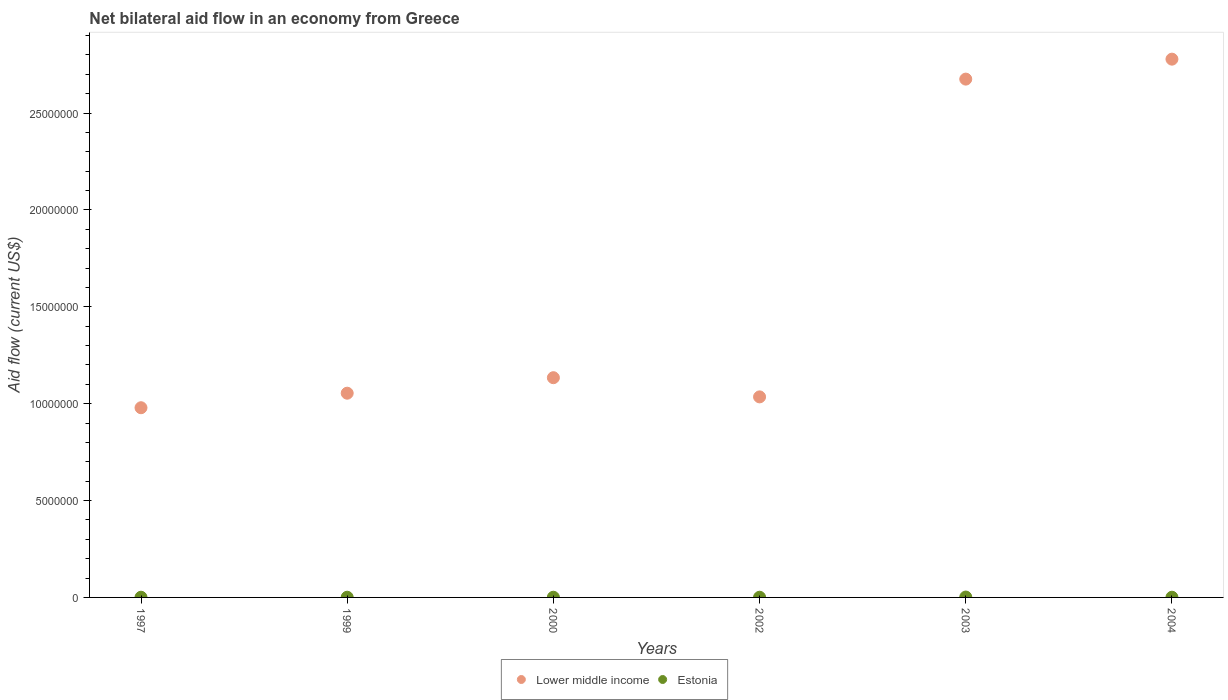Is the number of dotlines equal to the number of legend labels?
Your answer should be very brief. Yes. What is the net bilateral aid flow in Estonia in 2004?
Offer a very short reply. 10000. Across all years, what is the minimum net bilateral aid flow in Lower middle income?
Your response must be concise. 9.79e+06. What is the total net bilateral aid flow in Estonia in the graph?
Keep it short and to the point. 7.00e+04. What is the difference between the net bilateral aid flow in Lower middle income in 1999 and that in 2004?
Offer a terse response. -1.72e+07. What is the difference between the net bilateral aid flow in Lower middle income in 1999 and the net bilateral aid flow in Estonia in 2000?
Ensure brevity in your answer.  1.05e+07. What is the average net bilateral aid flow in Estonia per year?
Give a very brief answer. 1.17e+04. In the year 2004, what is the difference between the net bilateral aid flow in Lower middle income and net bilateral aid flow in Estonia?
Ensure brevity in your answer.  2.78e+07. In how many years, is the net bilateral aid flow in Estonia greater than 24000000 US$?
Your answer should be very brief. 0. What is the ratio of the net bilateral aid flow in Lower middle income in 2003 to that in 2004?
Your answer should be very brief. 0.96. Is the difference between the net bilateral aid flow in Lower middle income in 2000 and 2003 greater than the difference between the net bilateral aid flow in Estonia in 2000 and 2003?
Ensure brevity in your answer.  No. What is the difference between the highest and the lowest net bilateral aid flow in Lower middle income?
Ensure brevity in your answer.  1.80e+07. In how many years, is the net bilateral aid flow in Lower middle income greater than the average net bilateral aid flow in Lower middle income taken over all years?
Offer a terse response. 2. Is the sum of the net bilateral aid flow in Estonia in 1997 and 1999 greater than the maximum net bilateral aid flow in Lower middle income across all years?
Provide a succinct answer. No. How many dotlines are there?
Keep it short and to the point. 2. What is the difference between two consecutive major ticks on the Y-axis?
Your answer should be compact. 5.00e+06. Are the values on the major ticks of Y-axis written in scientific E-notation?
Give a very brief answer. No. How many legend labels are there?
Provide a succinct answer. 2. How are the legend labels stacked?
Ensure brevity in your answer.  Horizontal. What is the title of the graph?
Give a very brief answer. Net bilateral aid flow in an economy from Greece. Does "Cabo Verde" appear as one of the legend labels in the graph?
Offer a very short reply. No. What is the label or title of the X-axis?
Provide a short and direct response. Years. What is the label or title of the Y-axis?
Provide a succinct answer. Aid flow (current US$). What is the Aid flow (current US$) of Lower middle income in 1997?
Keep it short and to the point. 9.79e+06. What is the Aid flow (current US$) of Lower middle income in 1999?
Give a very brief answer. 1.05e+07. What is the Aid flow (current US$) of Estonia in 1999?
Offer a very short reply. 10000. What is the Aid flow (current US$) in Lower middle income in 2000?
Provide a short and direct response. 1.13e+07. What is the Aid flow (current US$) of Estonia in 2000?
Give a very brief answer. 10000. What is the Aid flow (current US$) of Lower middle income in 2002?
Make the answer very short. 1.04e+07. What is the Aid flow (current US$) of Estonia in 2002?
Your answer should be very brief. 10000. What is the Aid flow (current US$) of Lower middle income in 2003?
Provide a succinct answer. 2.68e+07. What is the Aid flow (current US$) of Estonia in 2003?
Provide a short and direct response. 2.00e+04. What is the Aid flow (current US$) of Lower middle income in 2004?
Make the answer very short. 2.78e+07. Across all years, what is the maximum Aid flow (current US$) of Lower middle income?
Ensure brevity in your answer.  2.78e+07. Across all years, what is the minimum Aid flow (current US$) of Lower middle income?
Make the answer very short. 9.79e+06. What is the total Aid flow (current US$) of Lower middle income in the graph?
Offer a terse response. 9.66e+07. What is the total Aid flow (current US$) of Estonia in the graph?
Provide a succinct answer. 7.00e+04. What is the difference between the Aid flow (current US$) in Lower middle income in 1997 and that in 1999?
Keep it short and to the point. -7.50e+05. What is the difference between the Aid flow (current US$) of Estonia in 1997 and that in 1999?
Offer a terse response. 0. What is the difference between the Aid flow (current US$) in Lower middle income in 1997 and that in 2000?
Give a very brief answer. -1.55e+06. What is the difference between the Aid flow (current US$) in Estonia in 1997 and that in 2000?
Provide a succinct answer. 0. What is the difference between the Aid flow (current US$) in Lower middle income in 1997 and that in 2002?
Make the answer very short. -5.60e+05. What is the difference between the Aid flow (current US$) of Lower middle income in 1997 and that in 2003?
Ensure brevity in your answer.  -1.70e+07. What is the difference between the Aid flow (current US$) of Estonia in 1997 and that in 2003?
Offer a very short reply. -10000. What is the difference between the Aid flow (current US$) in Lower middle income in 1997 and that in 2004?
Provide a succinct answer. -1.80e+07. What is the difference between the Aid flow (current US$) of Estonia in 1997 and that in 2004?
Provide a succinct answer. 0. What is the difference between the Aid flow (current US$) of Lower middle income in 1999 and that in 2000?
Provide a succinct answer. -8.00e+05. What is the difference between the Aid flow (current US$) of Estonia in 1999 and that in 2002?
Your answer should be very brief. 0. What is the difference between the Aid flow (current US$) of Lower middle income in 1999 and that in 2003?
Your answer should be compact. -1.62e+07. What is the difference between the Aid flow (current US$) of Lower middle income in 1999 and that in 2004?
Make the answer very short. -1.72e+07. What is the difference between the Aid flow (current US$) in Lower middle income in 2000 and that in 2002?
Ensure brevity in your answer.  9.90e+05. What is the difference between the Aid flow (current US$) of Estonia in 2000 and that in 2002?
Provide a succinct answer. 0. What is the difference between the Aid flow (current US$) of Lower middle income in 2000 and that in 2003?
Provide a short and direct response. -1.54e+07. What is the difference between the Aid flow (current US$) in Lower middle income in 2000 and that in 2004?
Give a very brief answer. -1.64e+07. What is the difference between the Aid flow (current US$) of Lower middle income in 2002 and that in 2003?
Keep it short and to the point. -1.64e+07. What is the difference between the Aid flow (current US$) of Lower middle income in 2002 and that in 2004?
Make the answer very short. -1.74e+07. What is the difference between the Aid flow (current US$) in Estonia in 2002 and that in 2004?
Give a very brief answer. 0. What is the difference between the Aid flow (current US$) of Lower middle income in 2003 and that in 2004?
Offer a very short reply. -1.03e+06. What is the difference between the Aid flow (current US$) in Estonia in 2003 and that in 2004?
Keep it short and to the point. 10000. What is the difference between the Aid flow (current US$) of Lower middle income in 1997 and the Aid flow (current US$) of Estonia in 1999?
Offer a terse response. 9.78e+06. What is the difference between the Aid flow (current US$) of Lower middle income in 1997 and the Aid flow (current US$) of Estonia in 2000?
Offer a very short reply. 9.78e+06. What is the difference between the Aid flow (current US$) in Lower middle income in 1997 and the Aid flow (current US$) in Estonia in 2002?
Give a very brief answer. 9.78e+06. What is the difference between the Aid flow (current US$) of Lower middle income in 1997 and the Aid flow (current US$) of Estonia in 2003?
Your response must be concise. 9.77e+06. What is the difference between the Aid flow (current US$) of Lower middle income in 1997 and the Aid flow (current US$) of Estonia in 2004?
Give a very brief answer. 9.78e+06. What is the difference between the Aid flow (current US$) of Lower middle income in 1999 and the Aid flow (current US$) of Estonia in 2000?
Your answer should be very brief. 1.05e+07. What is the difference between the Aid flow (current US$) in Lower middle income in 1999 and the Aid flow (current US$) in Estonia in 2002?
Make the answer very short. 1.05e+07. What is the difference between the Aid flow (current US$) of Lower middle income in 1999 and the Aid flow (current US$) of Estonia in 2003?
Give a very brief answer. 1.05e+07. What is the difference between the Aid flow (current US$) in Lower middle income in 1999 and the Aid flow (current US$) in Estonia in 2004?
Give a very brief answer. 1.05e+07. What is the difference between the Aid flow (current US$) of Lower middle income in 2000 and the Aid flow (current US$) of Estonia in 2002?
Your response must be concise. 1.13e+07. What is the difference between the Aid flow (current US$) of Lower middle income in 2000 and the Aid flow (current US$) of Estonia in 2003?
Your answer should be very brief. 1.13e+07. What is the difference between the Aid flow (current US$) in Lower middle income in 2000 and the Aid flow (current US$) in Estonia in 2004?
Make the answer very short. 1.13e+07. What is the difference between the Aid flow (current US$) in Lower middle income in 2002 and the Aid flow (current US$) in Estonia in 2003?
Make the answer very short. 1.03e+07. What is the difference between the Aid flow (current US$) of Lower middle income in 2002 and the Aid flow (current US$) of Estonia in 2004?
Your answer should be very brief. 1.03e+07. What is the difference between the Aid flow (current US$) in Lower middle income in 2003 and the Aid flow (current US$) in Estonia in 2004?
Keep it short and to the point. 2.67e+07. What is the average Aid flow (current US$) of Lower middle income per year?
Give a very brief answer. 1.61e+07. What is the average Aid flow (current US$) in Estonia per year?
Offer a terse response. 1.17e+04. In the year 1997, what is the difference between the Aid flow (current US$) in Lower middle income and Aid flow (current US$) in Estonia?
Make the answer very short. 9.78e+06. In the year 1999, what is the difference between the Aid flow (current US$) in Lower middle income and Aid flow (current US$) in Estonia?
Provide a succinct answer. 1.05e+07. In the year 2000, what is the difference between the Aid flow (current US$) of Lower middle income and Aid flow (current US$) of Estonia?
Your response must be concise. 1.13e+07. In the year 2002, what is the difference between the Aid flow (current US$) of Lower middle income and Aid flow (current US$) of Estonia?
Offer a very short reply. 1.03e+07. In the year 2003, what is the difference between the Aid flow (current US$) in Lower middle income and Aid flow (current US$) in Estonia?
Your answer should be very brief. 2.67e+07. In the year 2004, what is the difference between the Aid flow (current US$) of Lower middle income and Aid flow (current US$) of Estonia?
Give a very brief answer. 2.78e+07. What is the ratio of the Aid flow (current US$) of Lower middle income in 1997 to that in 1999?
Provide a short and direct response. 0.93. What is the ratio of the Aid flow (current US$) in Lower middle income in 1997 to that in 2000?
Give a very brief answer. 0.86. What is the ratio of the Aid flow (current US$) of Lower middle income in 1997 to that in 2002?
Keep it short and to the point. 0.95. What is the ratio of the Aid flow (current US$) of Lower middle income in 1997 to that in 2003?
Provide a succinct answer. 0.37. What is the ratio of the Aid flow (current US$) in Lower middle income in 1997 to that in 2004?
Offer a terse response. 0.35. What is the ratio of the Aid flow (current US$) of Estonia in 1997 to that in 2004?
Give a very brief answer. 1. What is the ratio of the Aid flow (current US$) in Lower middle income in 1999 to that in 2000?
Ensure brevity in your answer.  0.93. What is the ratio of the Aid flow (current US$) of Lower middle income in 1999 to that in 2002?
Provide a short and direct response. 1.02. What is the ratio of the Aid flow (current US$) of Lower middle income in 1999 to that in 2003?
Provide a short and direct response. 0.39. What is the ratio of the Aid flow (current US$) of Lower middle income in 1999 to that in 2004?
Your response must be concise. 0.38. What is the ratio of the Aid flow (current US$) of Lower middle income in 2000 to that in 2002?
Make the answer very short. 1.1. What is the ratio of the Aid flow (current US$) of Estonia in 2000 to that in 2002?
Make the answer very short. 1. What is the ratio of the Aid flow (current US$) of Lower middle income in 2000 to that in 2003?
Keep it short and to the point. 0.42. What is the ratio of the Aid flow (current US$) of Estonia in 2000 to that in 2003?
Your answer should be compact. 0.5. What is the ratio of the Aid flow (current US$) of Lower middle income in 2000 to that in 2004?
Offer a terse response. 0.41. What is the ratio of the Aid flow (current US$) in Lower middle income in 2002 to that in 2003?
Your answer should be compact. 0.39. What is the ratio of the Aid flow (current US$) of Estonia in 2002 to that in 2003?
Keep it short and to the point. 0.5. What is the ratio of the Aid flow (current US$) of Lower middle income in 2002 to that in 2004?
Keep it short and to the point. 0.37. What is the ratio of the Aid flow (current US$) in Lower middle income in 2003 to that in 2004?
Provide a succinct answer. 0.96. What is the difference between the highest and the second highest Aid flow (current US$) of Lower middle income?
Ensure brevity in your answer.  1.03e+06. What is the difference between the highest and the second highest Aid flow (current US$) in Estonia?
Ensure brevity in your answer.  10000. What is the difference between the highest and the lowest Aid flow (current US$) of Lower middle income?
Your answer should be very brief. 1.80e+07. What is the difference between the highest and the lowest Aid flow (current US$) in Estonia?
Provide a short and direct response. 10000. 